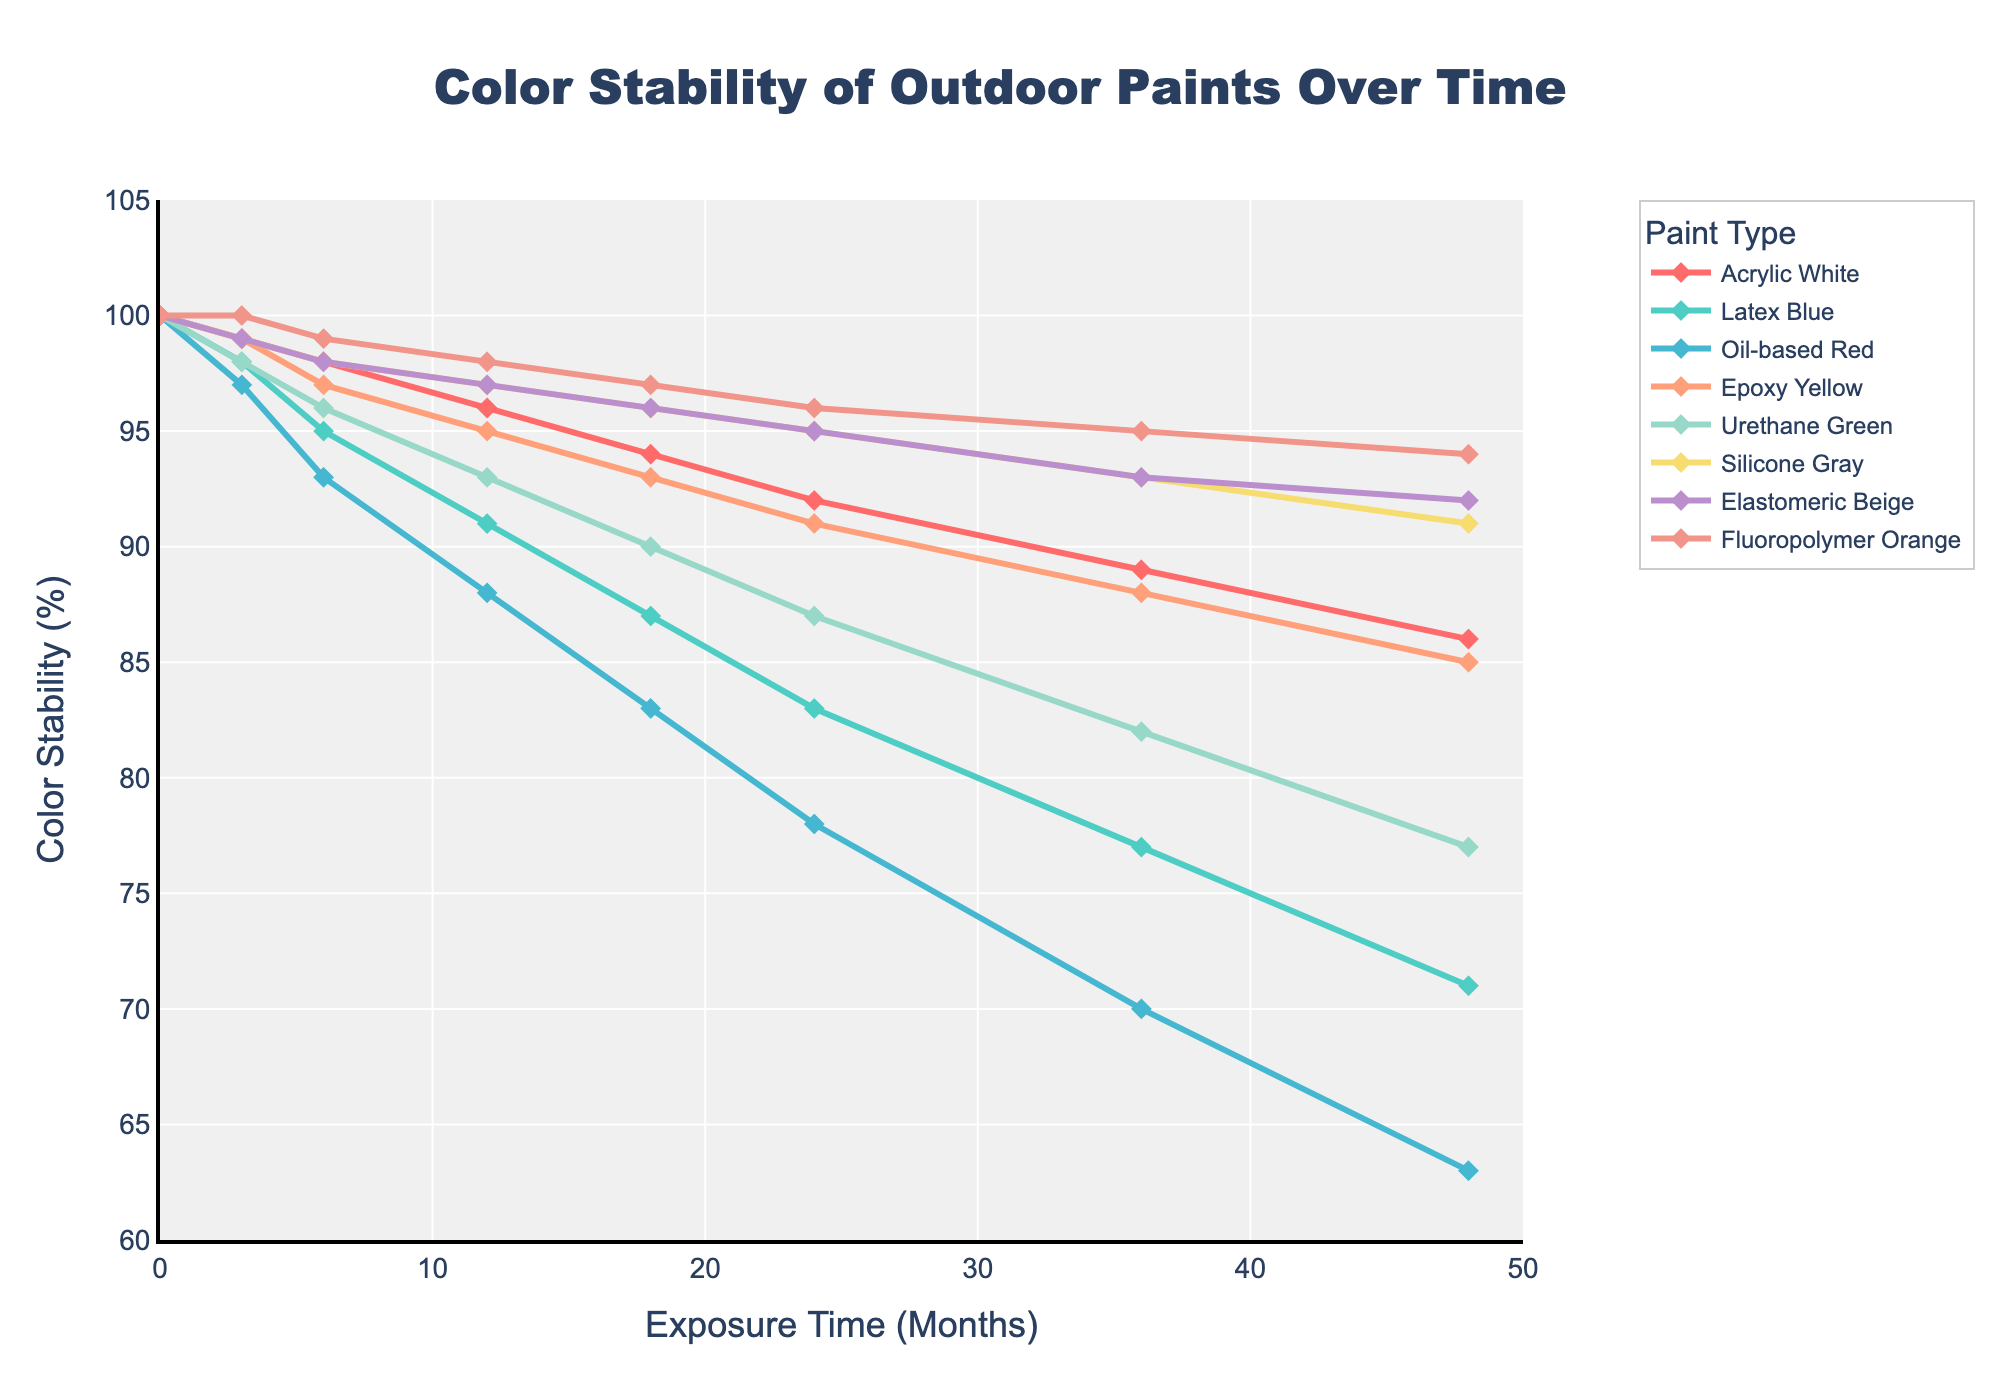Which paint shows the highest color stability throughout the 48 months? To determine the paint with the highest color stability over time, observe the line representing each paint color. The one that stays closest to 100% across all time points is the one with the highest stability. In this case, Fluoropolymer Orange displays the highest stability, maintaining around 94% after 48 months.
Answer: Fluoropolymer Orange Which paint exhibits the steepest decline in color stability within the first 6 months? To find the steepest decline within the first 6 months, look at the lines between 0 and 6 months and measure the drop in percentage. Oil-based Red drops from 100% to 93%, which is a 7% decrease—the most significant decline compared to the other paints within this period.
Answer: Oil-based Red What is the total percentage decrease in color stability for Urethane Green from 0 months to 48 months? The color stability of Urethane Green drops from 100% at 0 months to 77% at 48 months. To find the total decrease, subtract the final percentage from the initial: 100% - 77% = 23%.
Answer: 23% Compare the color stability of Silicone Gray and Acrylic White at 24 months. Which paint shows better stability? To compare these two paints at 24 months, look at their stability percentages at this point. Silicone Gray is at 95%, while Acrylic White is at 92%, indicating that Silicone Gray has better stability at this time point.
Answer: Silicone Gray What is the average color stability of Epoxy Yellow over the entire period of 48 months? To find the average stability, sum the percentages for Epoxy Yellow at each time point and divide by the total number of observations (8). (100 + 99 + 97 + 95 + 93 + 91 + 88 + 85) / 8 = 93.5%.
Answer: 93.5% Which paint shows the second-lowest color stability at 48 months? To find the second-lowest stability at 48 months, list the percentages at 48 months and identify the second smallest value. Oil-based Red is lowest at 63%, followed by Latex Blue at 71%.
Answer: Latex Blue How does the color stability of Elastomeric Beige at 36 months compare to its stability at 0 months? At 0 months, Elastomeric Beige is at 100%, and at 36 months it is at 93%. To compare, subtract the value at 36 months from the value at 0 months: 100% - 93% = 7%. Elastomeric Beige decreased by 7%.
Answer: Decreased by 7% Does any paint maintain 100% color stability at any time point beyond 0 months? From the visual inspection of the graph, only Fluoropolymer Orange and Silicone Gray maintain 100% color stability at the 3-month mark.
Answer: Yes What is the difference in color stability between the highest and lowest performing paints at 48 months? At 48 months, the highest performing paint is Fluoropolymer Orange at 94%, and the lowest is Oil-based Red at 63%. The difference is calculated as 94% - 63% = 31%.
Answer: 31% Is there a paint whose color stability decreases consistently over time without any increase? Observing the lines, Oil-based Red shows a consistent decrease over time across all time points.
Answer: Oil-based Red 